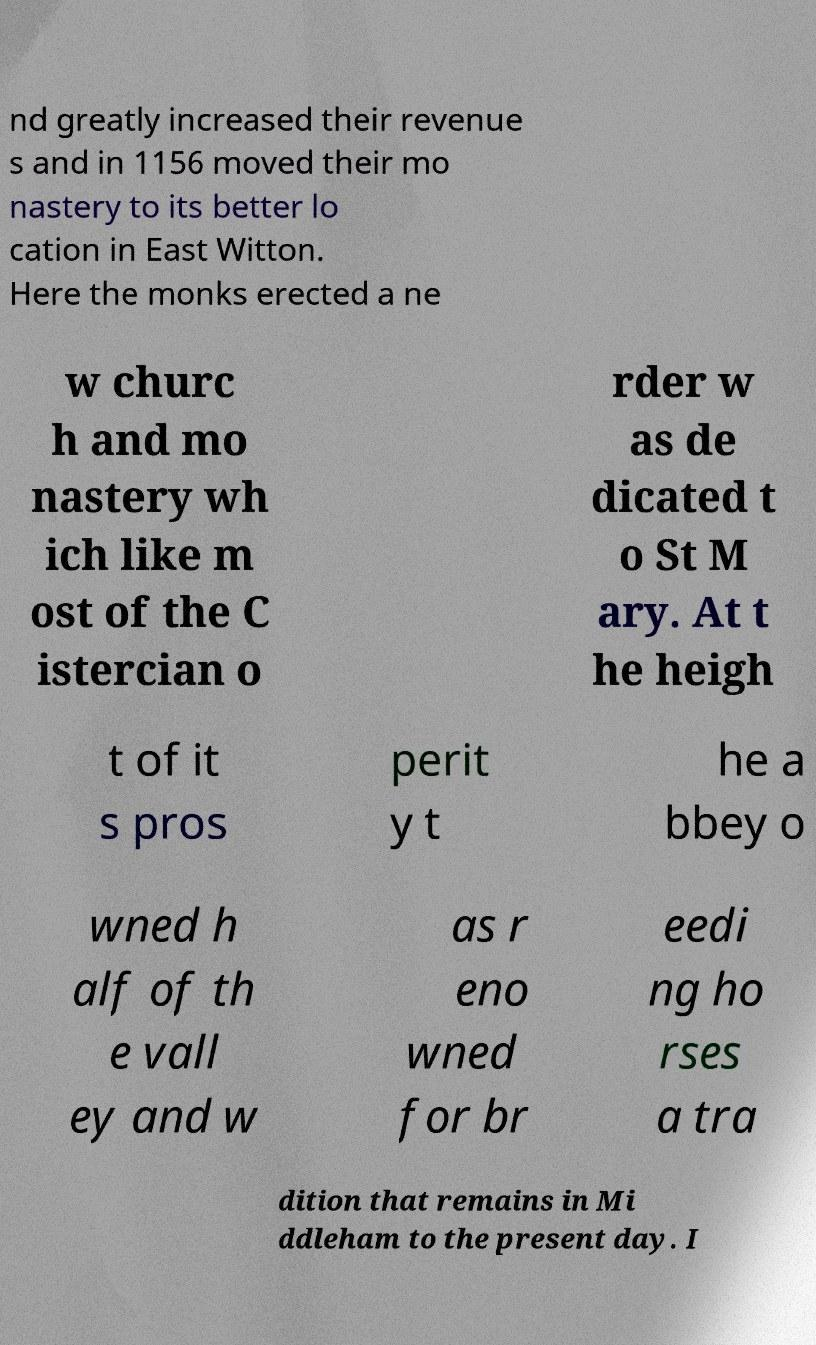I need the written content from this picture converted into text. Can you do that? nd greatly increased their revenue s and in 1156 moved their mo nastery to its better lo cation in East Witton. Here the monks erected a ne w churc h and mo nastery wh ich like m ost of the C istercian o rder w as de dicated t o St M ary. At t he heigh t of it s pros perit y t he a bbey o wned h alf of th e vall ey and w as r eno wned for br eedi ng ho rses a tra dition that remains in Mi ddleham to the present day. I 